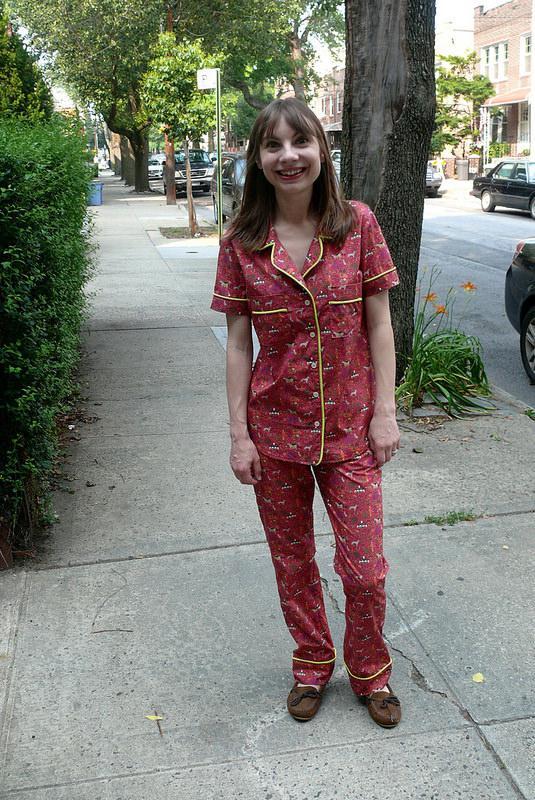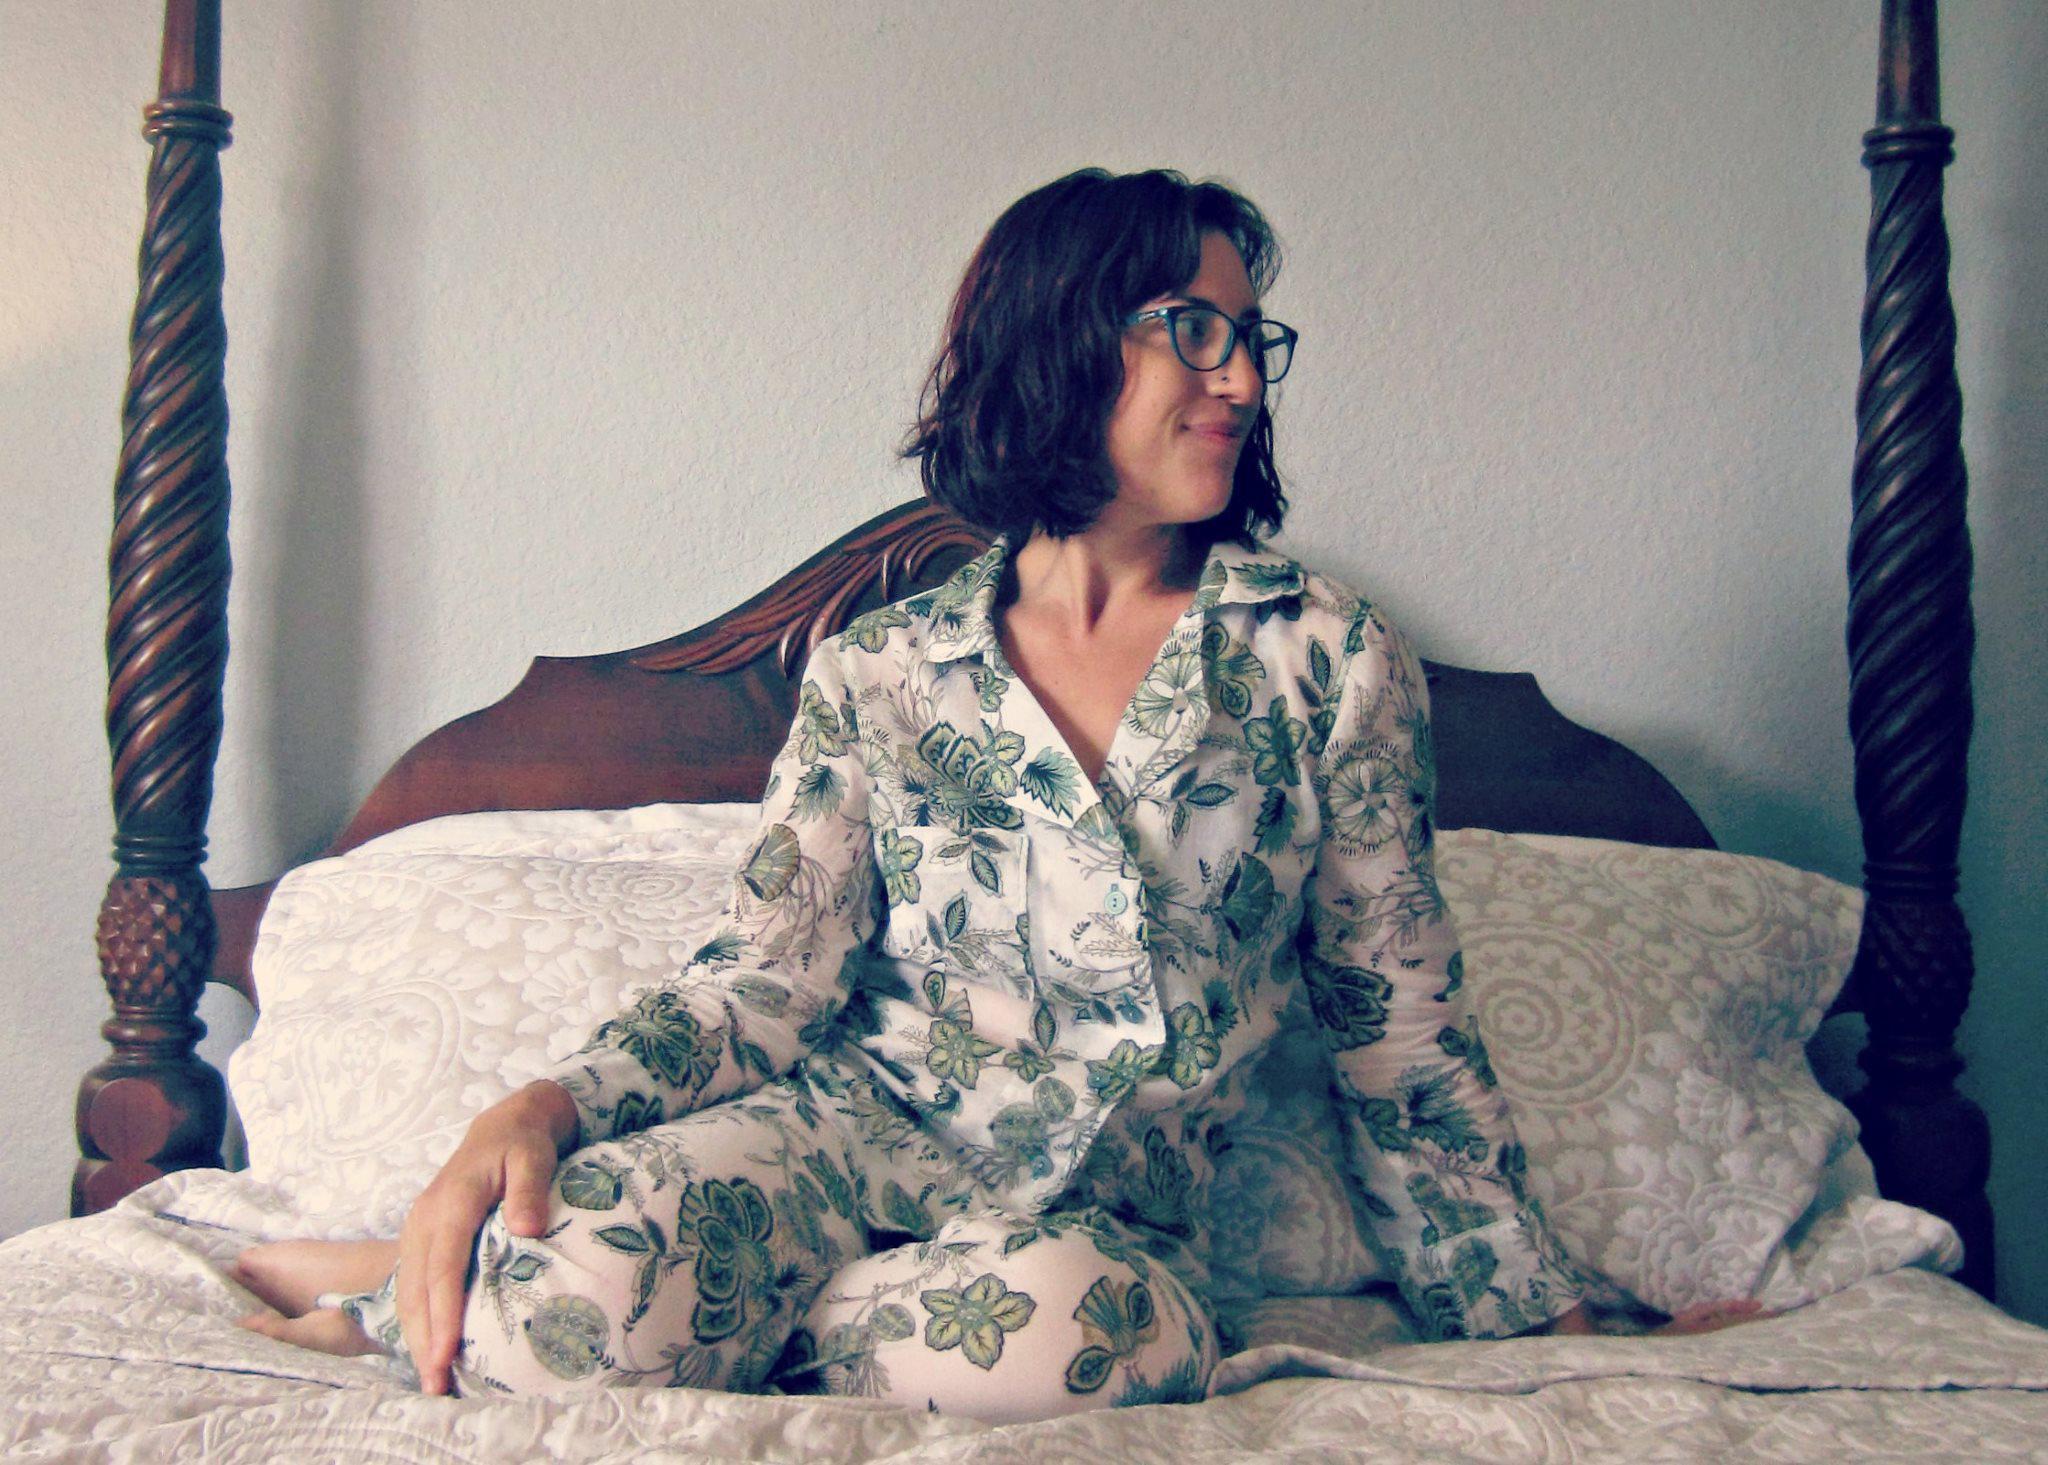The first image is the image on the left, the second image is the image on the right. For the images shown, is this caption "One image has two ladies with one of the ladies wearing shorts." true? Answer yes or no. No. 